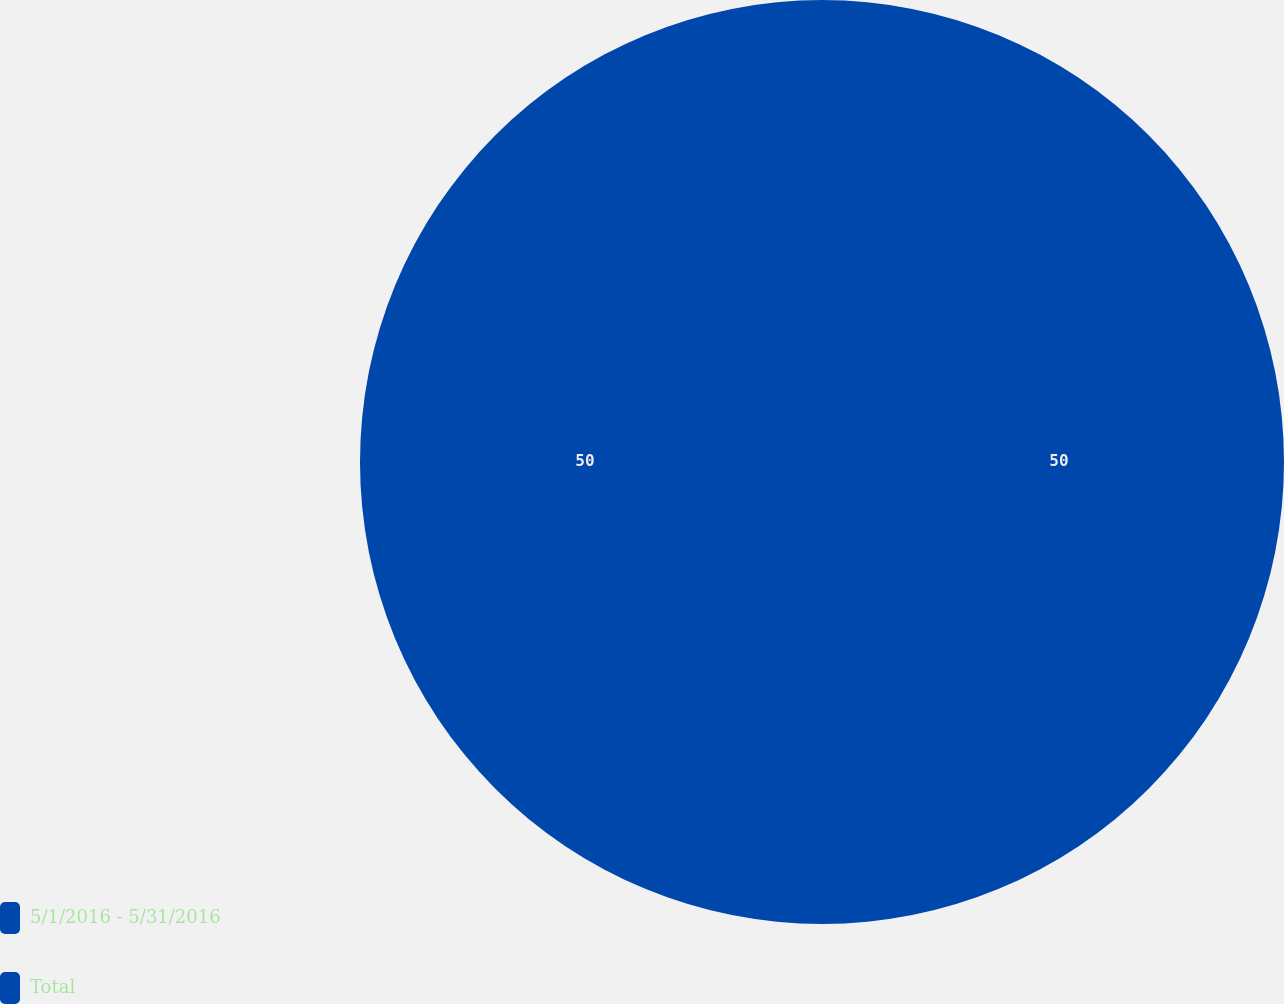<chart> <loc_0><loc_0><loc_500><loc_500><pie_chart><fcel>5/1/2016 - 5/31/2016<fcel>Total<nl><fcel>50.0%<fcel>50.0%<nl></chart> 